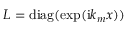Convert formula to latex. <formula><loc_0><loc_0><loc_500><loc_500>L = d i a g ( \exp ( i k _ { m } x ) )</formula> 